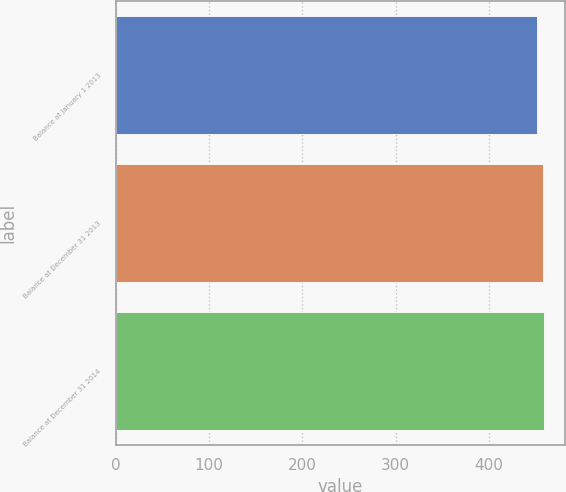Convert chart to OTSL. <chart><loc_0><loc_0><loc_500><loc_500><bar_chart><fcel>Balance at January 1 2013<fcel>Balance at December 31 2013<fcel>Balance at December 31 2014<nl><fcel>451<fcel>458<fcel>458.7<nl></chart> 